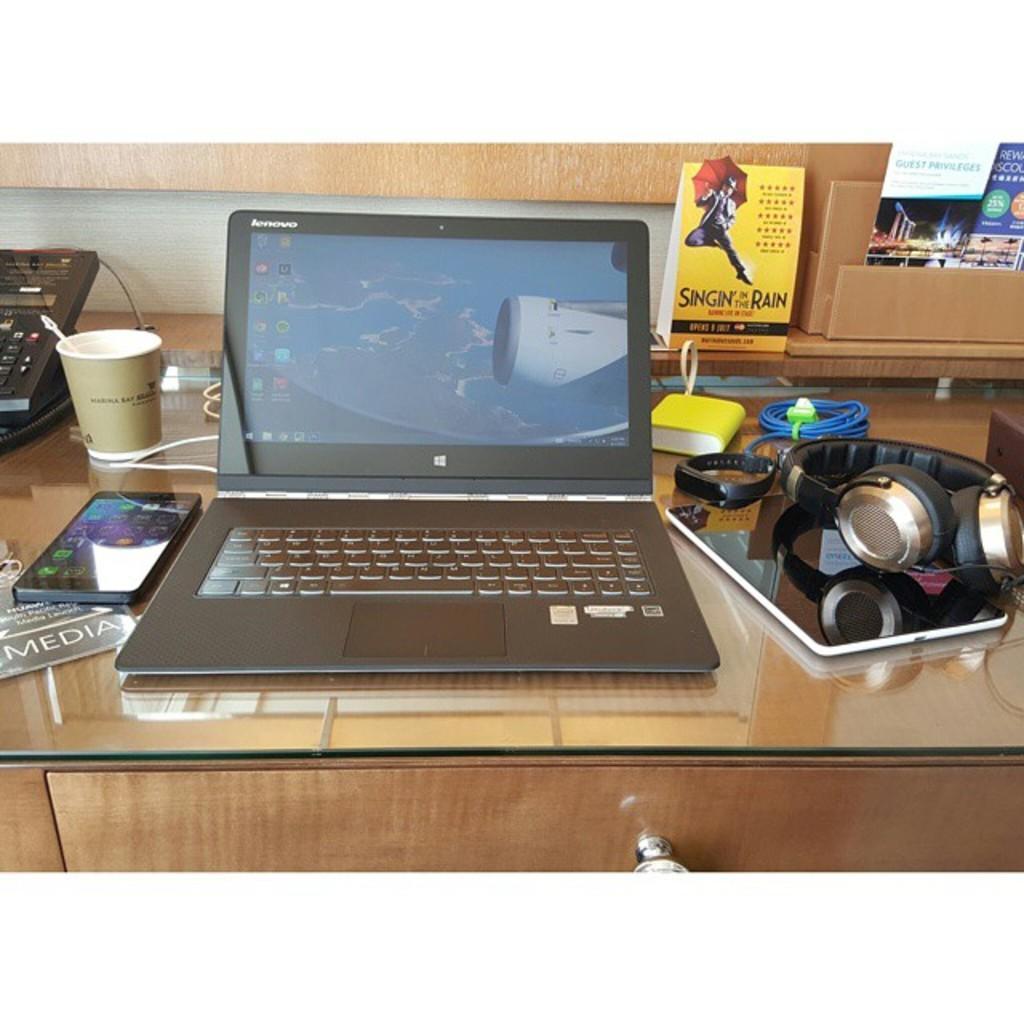Can you describe this image briefly? In this picture we can see a table. On the table there is a laptop, mobile, and a glass. This is headset. 